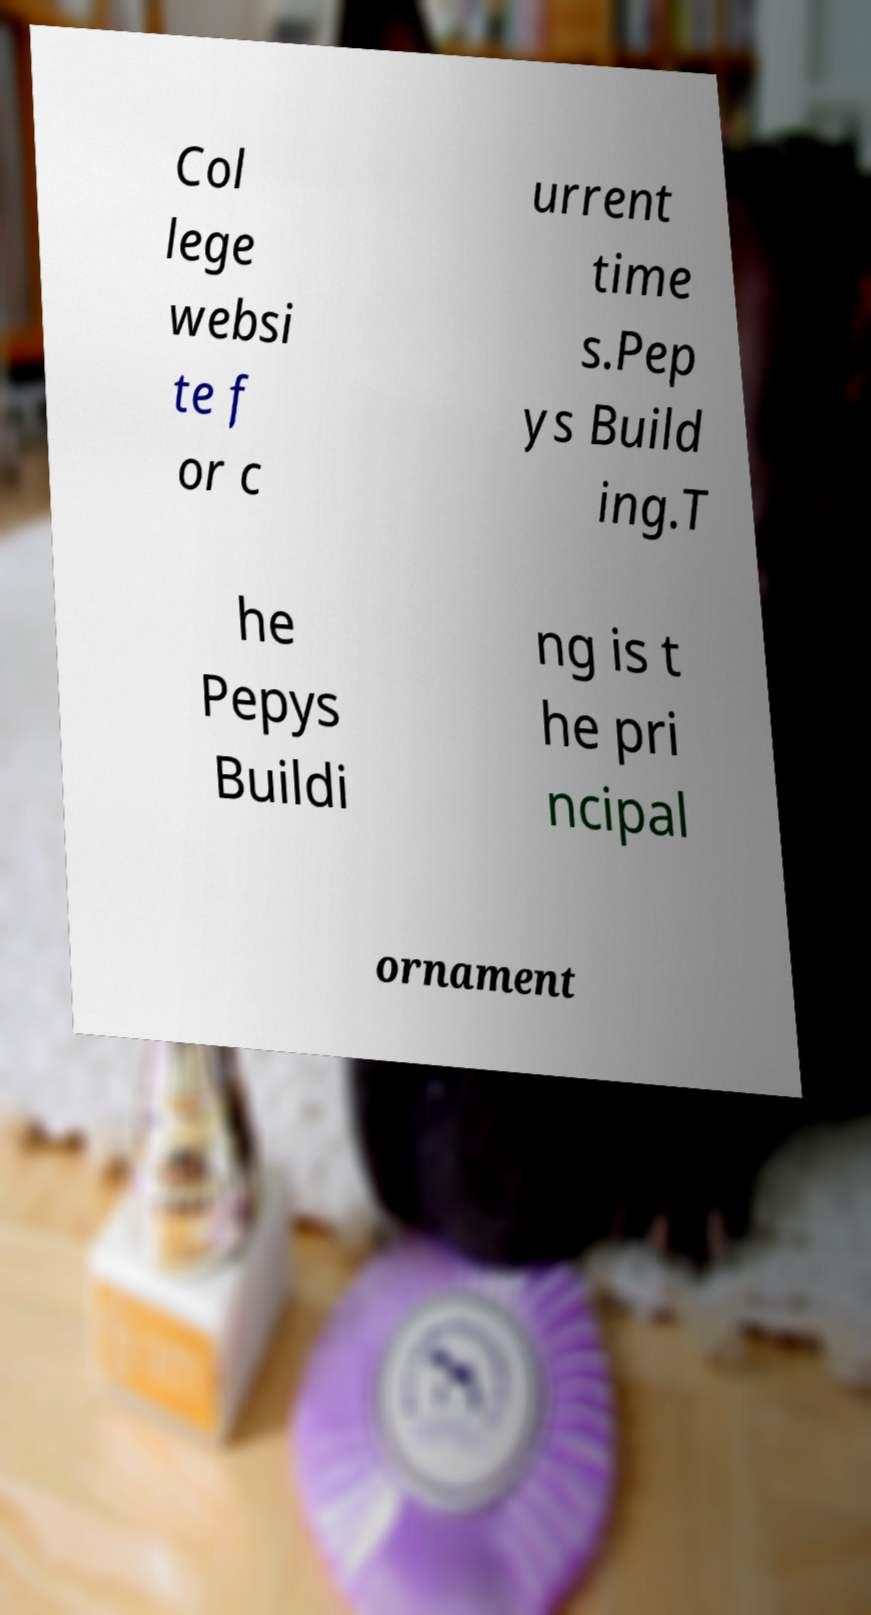Please identify and transcribe the text found in this image. Col lege websi te f or c urrent time s.Pep ys Build ing.T he Pepys Buildi ng is t he pri ncipal ornament 